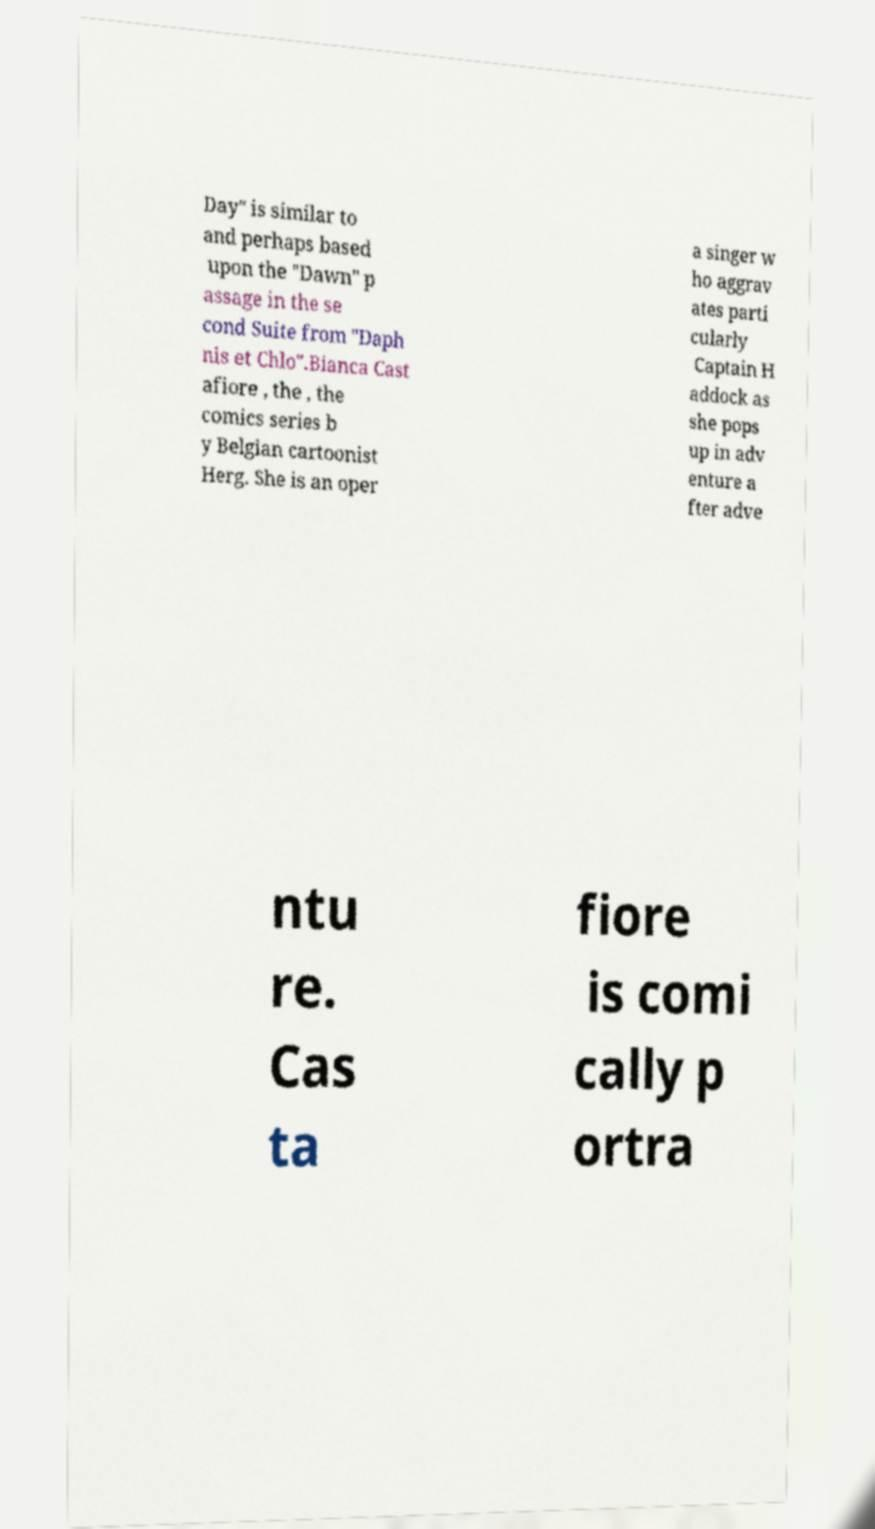Please read and relay the text visible in this image. What does it say? Day" is similar to and perhaps based upon the "Dawn" p assage in the se cond Suite from "Daph nis et Chlo".Bianca Cast afiore , the , the comics series b y Belgian cartoonist Herg. She is an oper a singer w ho aggrav ates parti cularly Captain H addock as she pops up in adv enture a fter adve ntu re. Cas ta fiore is comi cally p ortra 